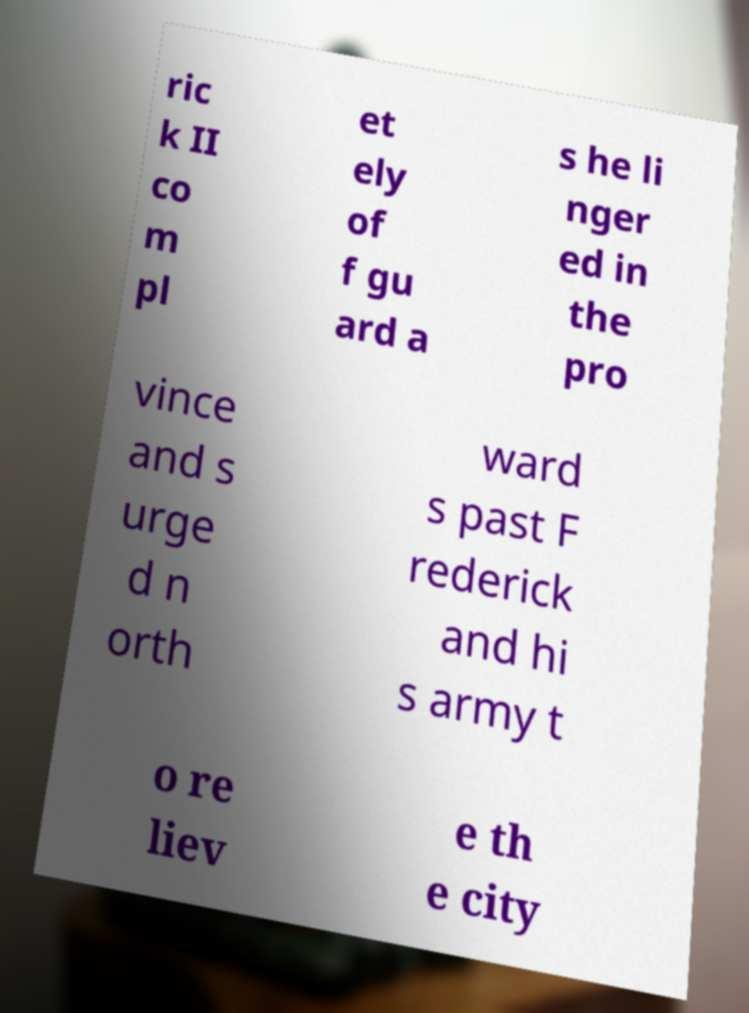Please read and relay the text visible in this image. What does it say? ric k II co m pl et ely of f gu ard a s he li nger ed in the pro vince and s urge d n orth ward s past F rederick and hi s army t o re liev e th e city 